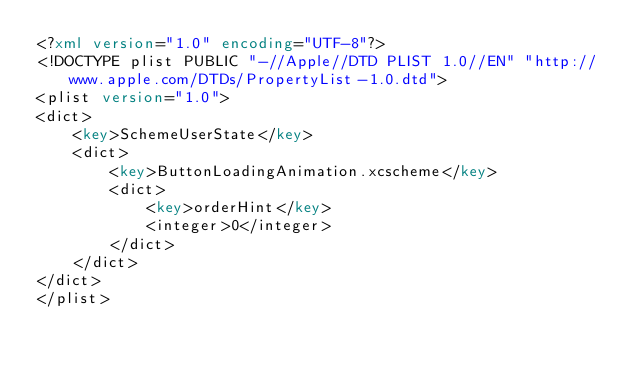Convert code to text. <code><loc_0><loc_0><loc_500><loc_500><_XML_><?xml version="1.0" encoding="UTF-8"?>
<!DOCTYPE plist PUBLIC "-//Apple//DTD PLIST 1.0//EN" "http://www.apple.com/DTDs/PropertyList-1.0.dtd">
<plist version="1.0">
<dict>
	<key>SchemeUserState</key>
	<dict>
		<key>ButtonLoadingAnimation.xcscheme</key>
		<dict>
			<key>orderHint</key>
			<integer>0</integer>
		</dict>
	</dict>
</dict>
</plist>
</code> 